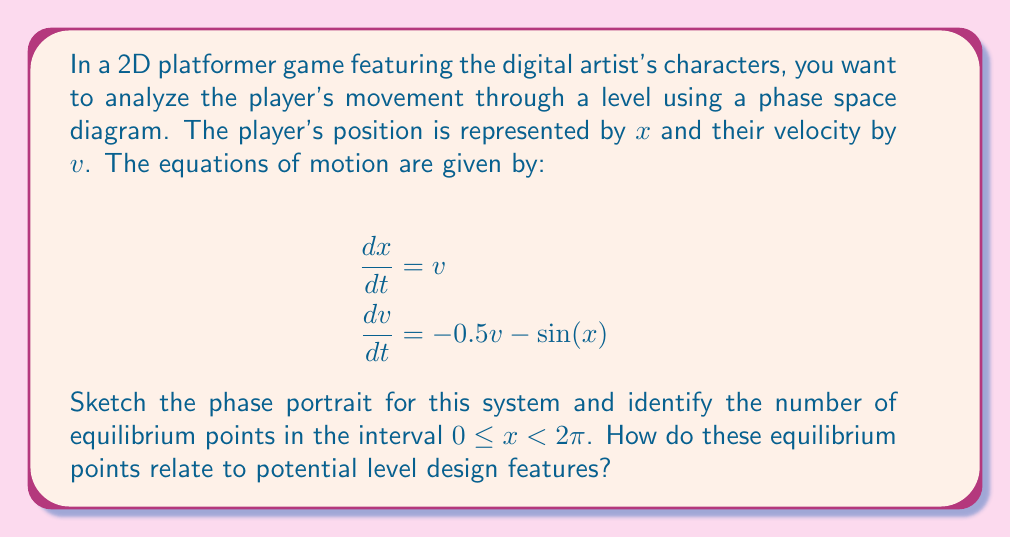Can you answer this question? 1. To sketch the phase portrait, we need to analyze the system of equations:
   $$\frac{dx}{dt} = v$$
   $$\frac{dv}{dt} = -0.5v - \sin(x)$$

2. First, let's find the equilibrium points by setting both equations to zero:
   $v = 0$
   $-0.5(0) - \sin(x) = 0$
   $\sin(x) = 0$

3. In the interval $0 \leq x < 2\pi$, $\sin(x) = 0$ occurs at $x = 0$ and $x = \pi$. Thus, there are two equilibrium points: $(0, 0)$ and $(\pi, 0)$.

4. To sketch the phase portrait, we can use the following information:
   - When $v > 0$, $x$ increases (move right in the phase space)
   - When $v < 0$, $x$ decreases (move left in the phase space)
   - When $-\sin(x) > 0.5v$, $v$ increases (move up in the phase space)
   - When $-\sin(x) < 0.5v$, $v$ decreases (move down in the phase space)

5. The phase portrait would look like this:

[asy]
import graph;
size(200,200);

xaxis("x",Arrow);
yaxis("v",Arrow);

real f(real x, real y) { return y; }
real g(real x, real y) { return -0.5*y - sin(x); }

add(vectorfield(f,g,(0,0),(2pi,2),1.5,blue));

dot((0,0));
dot((pi,0));
label("(0,0)",(0,0),SW);
label("(π,0)",(pi,0),SE);
[/asy]

6. Interpretation for level design:
   - The equilibrium point at $(0, 0)$ represents a stable position where the player naturally comes to rest. This could be a flat platform or a valley in the level.
   - The equilibrium point at $(\pi, 0)$ is unstable, representing a position of unstable balance. This could be the peak of a hill or a narrow ledge in the level.
   - The curved trajectories in the phase space represent the player's motion through the level, with oscillations around the stable point and divergence from the unstable point.
Answer: 2 equilibrium points: stable platform/valley at $(0,0)$, unstable peak/ledge at $(\pi,0)$ 